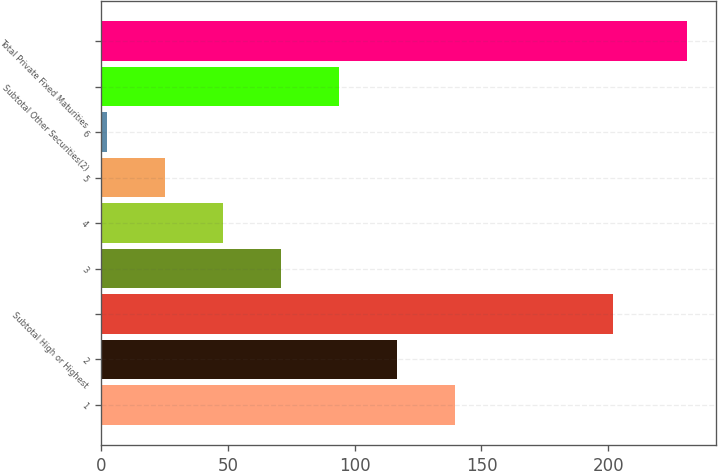Convert chart. <chart><loc_0><loc_0><loc_500><loc_500><bar_chart><fcel>1<fcel>2<fcel>Subtotal High or Highest<fcel>3<fcel>4<fcel>5<fcel>6<fcel>Subtotal Other Securities(2)<fcel>Total Private Fixed Maturities<nl><fcel>139.4<fcel>116.5<fcel>202<fcel>70.7<fcel>47.8<fcel>24.9<fcel>2<fcel>93.6<fcel>231<nl></chart> 